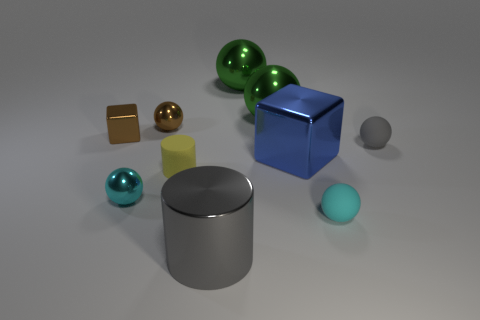Subtract all tiny rubber balls. How many balls are left? 4 Subtract all green spheres. How many spheres are left? 4 Subtract 2 cylinders. How many cylinders are left? 0 Subtract all blue cylinders. Subtract all green spheres. How many cylinders are left? 2 Subtract all brown cylinders. How many yellow blocks are left? 0 Subtract all cylinders. Subtract all big metal cylinders. How many objects are left? 7 Add 2 small yellow matte cylinders. How many small yellow matte cylinders are left? 3 Add 4 green shiny balls. How many green shiny balls exist? 6 Subtract 0 yellow spheres. How many objects are left? 10 Subtract all spheres. How many objects are left? 4 